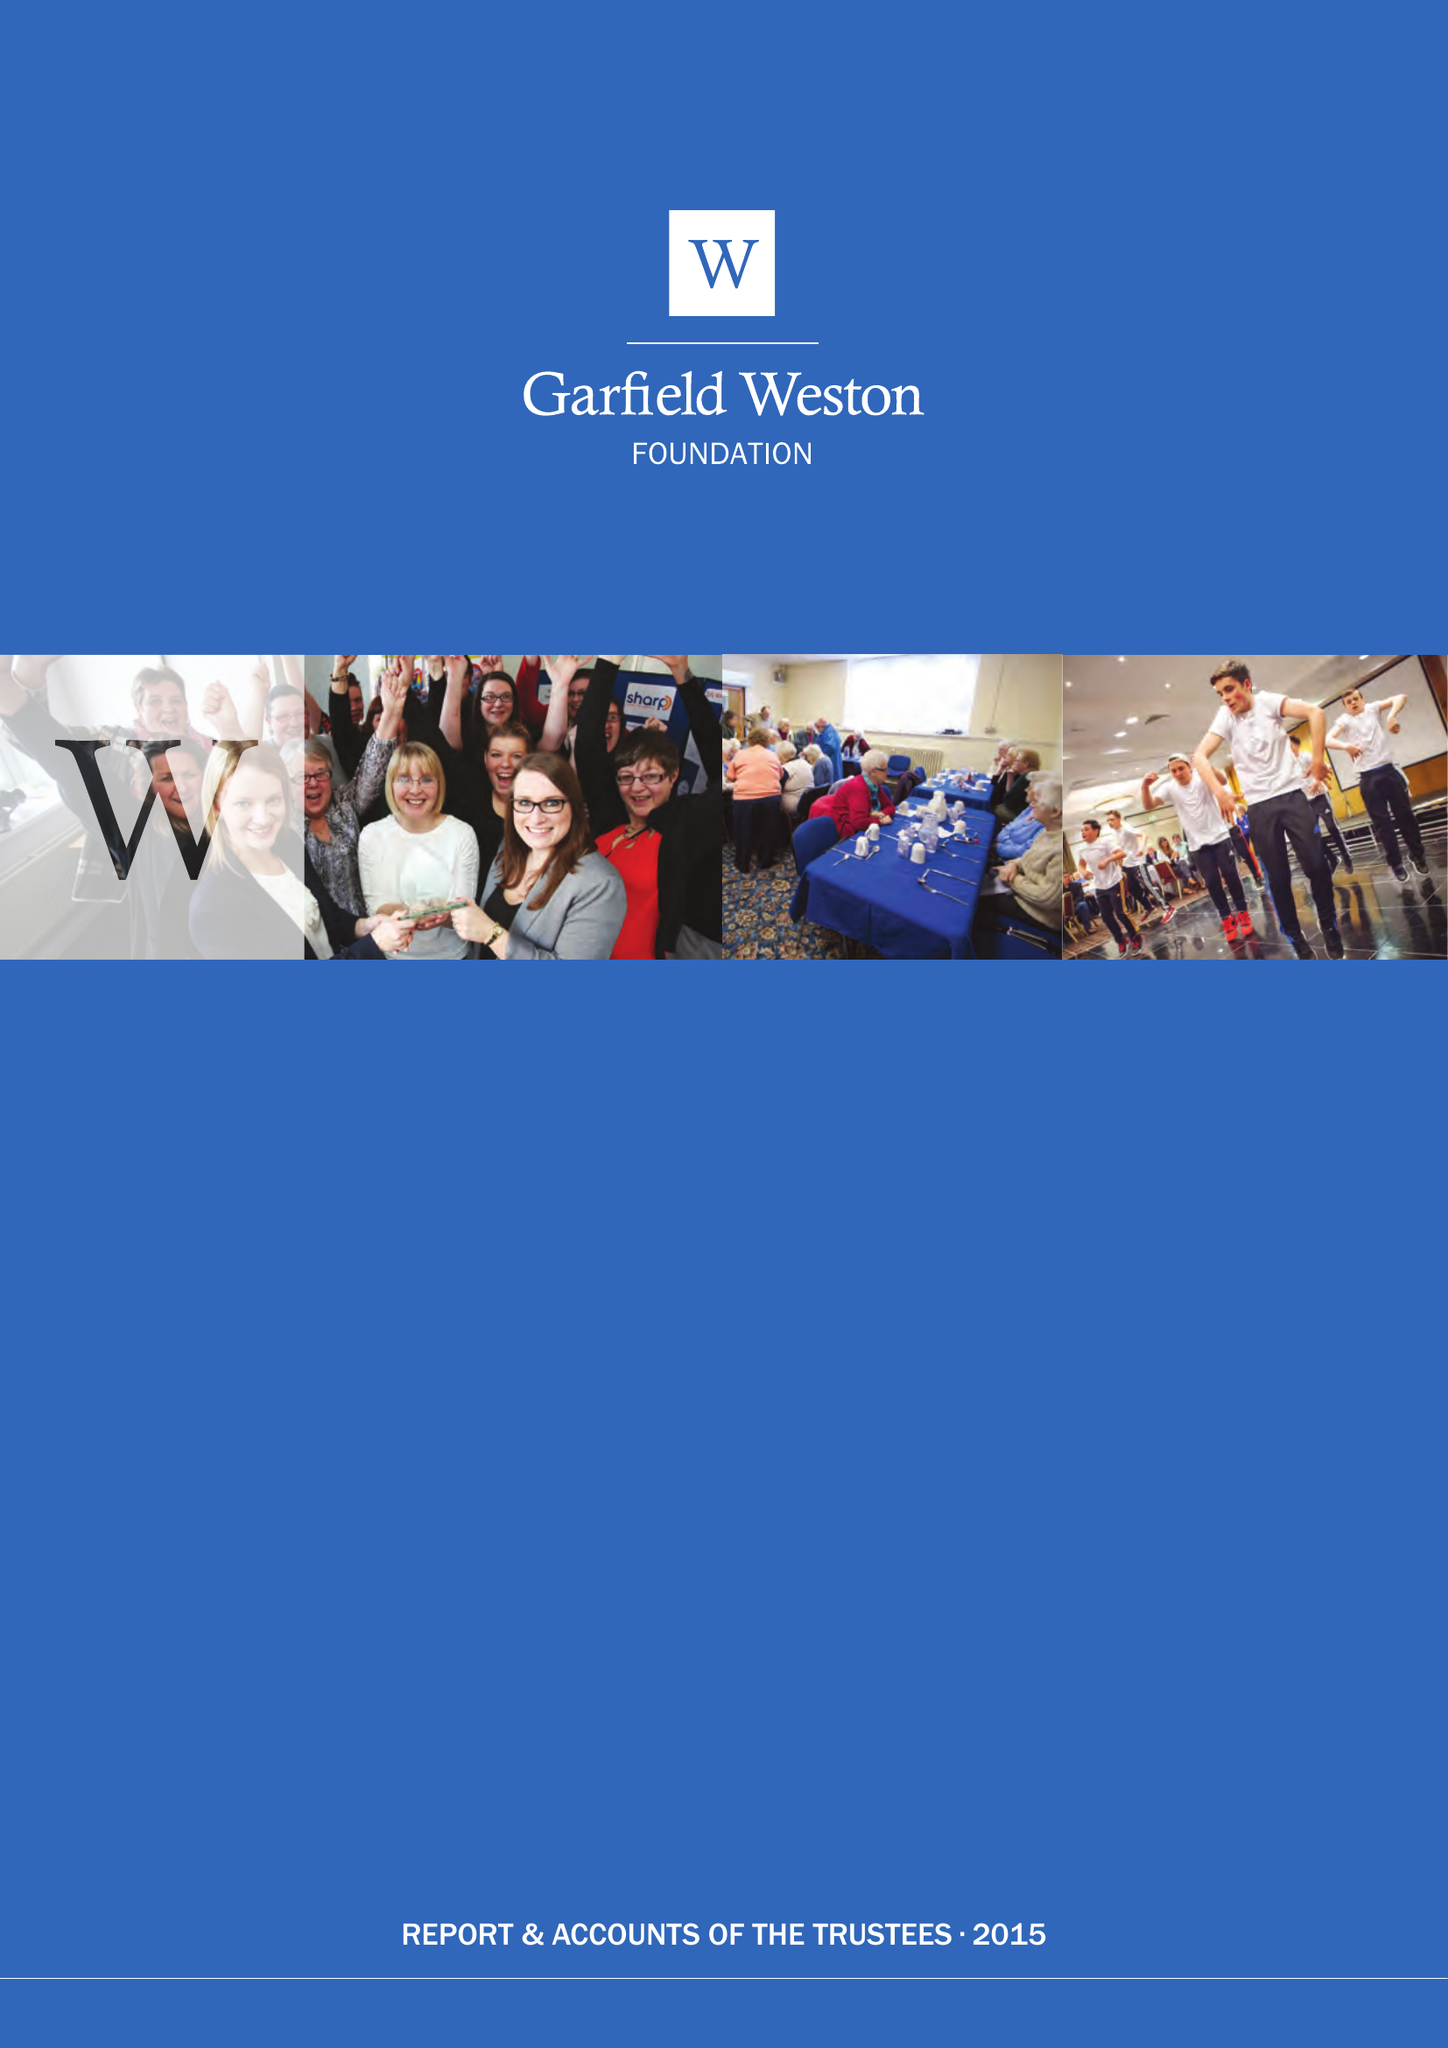What is the value for the address__post_town?
Answer the question using a single word or phrase. LONDON 